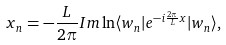<formula> <loc_0><loc_0><loc_500><loc_500>x _ { n } = - \frac { L } { 2 \pi } I m \ln \langle w _ { n } | e ^ { - i \frac { 2 \pi } { L } x } | w _ { n } \rangle ,</formula> 